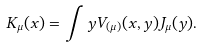<formula> <loc_0><loc_0><loc_500><loc_500>K _ { \mu } ( x ) = \int y V _ { ( \mu ) } ( x , y ) J _ { \mu } ( y ) .</formula> 